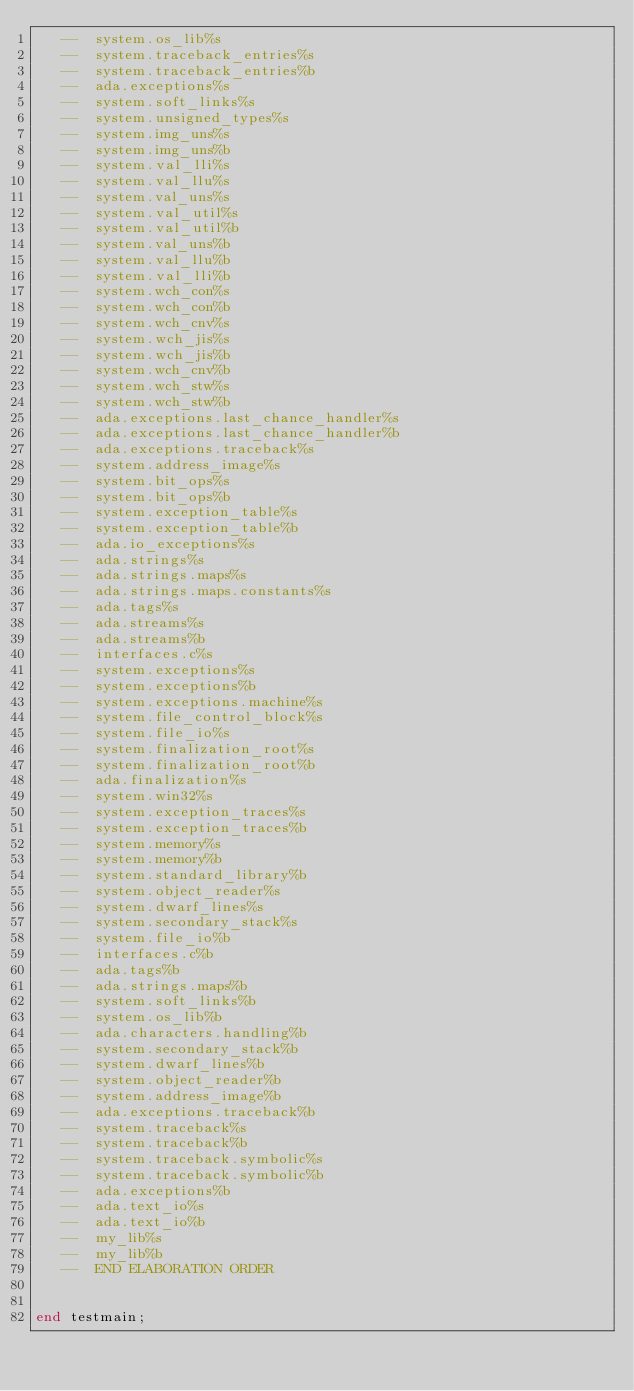<code> <loc_0><loc_0><loc_500><loc_500><_Ada_>   --  system.os_lib%s
   --  system.traceback_entries%s
   --  system.traceback_entries%b
   --  ada.exceptions%s
   --  system.soft_links%s
   --  system.unsigned_types%s
   --  system.img_uns%s
   --  system.img_uns%b
   --  system.val_lli%s
   --  system.val_llu%s
   --  system.val_uns%s
   --  system.val_util%s
   --  system.val_util%b
   --  system.val_uns%b
   --  system.val_llu%b
   --  system.val_lli%b
   --  system.wch_con%s
   --  system.wch_con%b
   --  system.wch_cnv%s
   --  system.wch_jis%s
   --  system.wch_jis%b
   --  system.wch_cnv%b
   --  system.wch_stw%s
   --  system.wch_stw%b
   --  ada.exceptions.last_chance_handler%s
   --  ada.exceptions.last_chance_handler%b
   --  ada.exceptions.traceback%s
   --  system.address_image%s
   --  system.bit_ops%s
   --  system.bit_ops%b
   --  system.exception_table%s
   --  system.exception_table%b
   --  ada.io_exceptions%s
   --  ada.strings%s
   --  ada.strings.maps%s
   --  ada.strings.maps.constants%s
   --  ada.tags%s
   --  ada.streams%s
   --  ada.streams%b
   --  interfaces.c%s
   --  system.exceptions%s
   --  system.exceptions%b
   --  system.exceptions.machine%s
   --  system.file_control_block%s
   --  system.file_io%s
   --  system.finalization_root%s
   --  system.finalization_root%b
   --  ada.finalization%s
   --  system.win32%s
   --  system.exception_traces%s
   --  system.exception_traces%b
   --  system.memory%s
   --  system.memory%b
   --  system.standard_library%b
   --  system.object_reader%s
   --  system.dwarf_lines%s
   --  system.secondary_stack%s
   --  system.file_io%b
   --  interfaces.c%b
   --  ada.tags%b
   --  ada.strings.maps%b
   --  system.soft_links%b
   --  system.os_lib%b
   --  ada.characters.handling%b
   --  system.secondary_stack%b
   --  system.dwarf_lines%b
   --  system.object_reader%b
   --  system.address_image%b
   --  ada.exceptions.traceback%b
   --  system.traceback%s
   --  system.traceback%b
   --  system.traceback.symbolic%s
   --  system.traceback.symbolic%b
   --  ada.exceptions%b
   --  ada.text_io%s
   --  ada.text_io%b
   --  my_lib%s
   --  my_lib%b
   --  END ELABORATION ORDER


end testmain;
</code> 